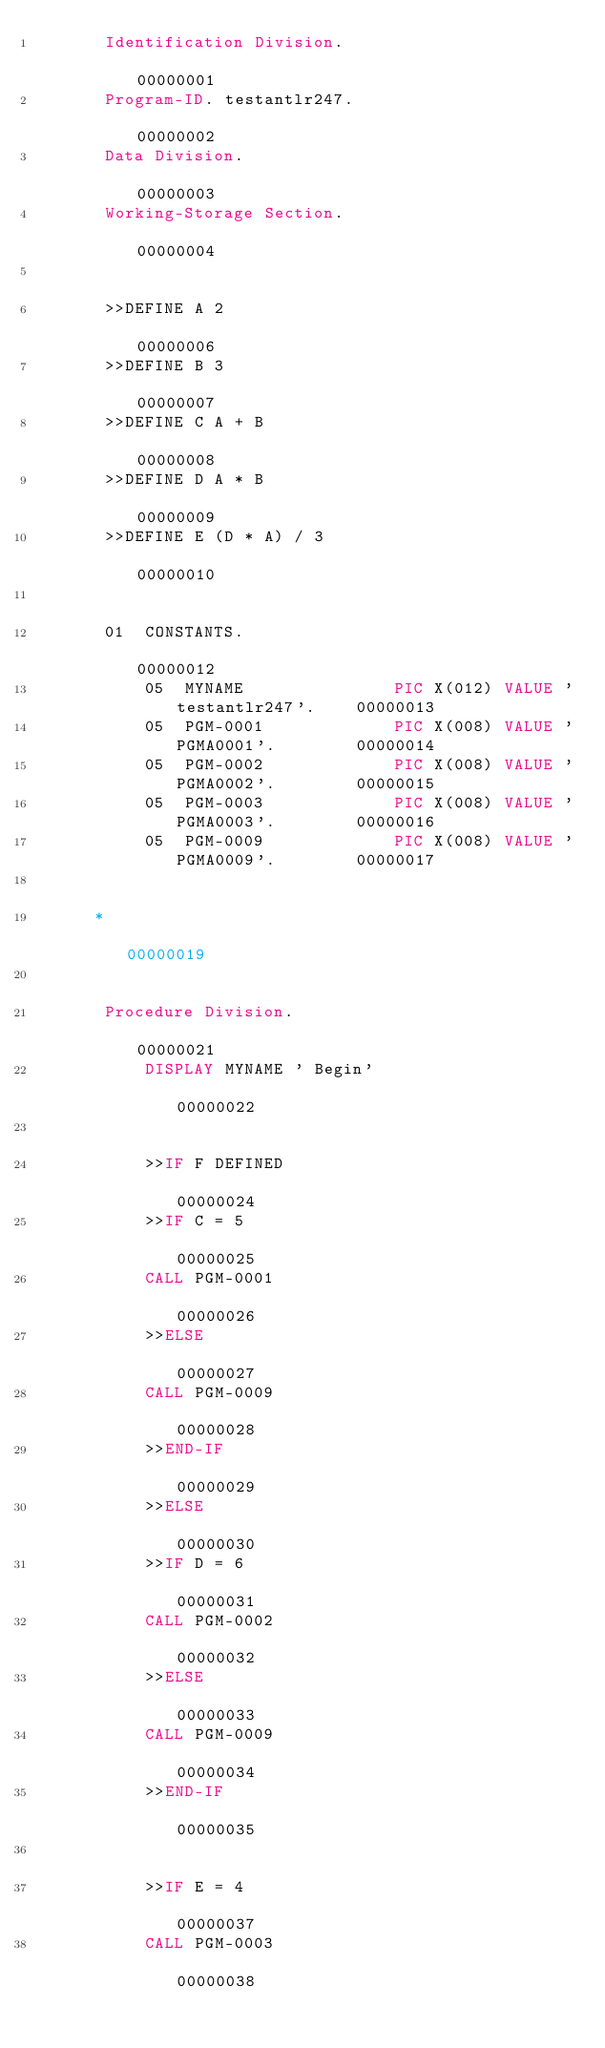<code> <loc_0><loc_0><loc_500><loc_500><_COBOL_>       Identification Division.                                         00000001
       Program-ID. testantlr247.                                        00000002
       Data Division.                                                   00000003
       Working-Storage Section.                                         00000004
                                                                        00000005
       >>DEFINE A 2                                                     00000006
       >>DEFINE B 3                                                     00000007
       >>DEFINE C A + B                                                 00000008
       >>DEFINE D A * B                                                 00000009
       >>DEFINE E (D * A) / 3                                           00000010
                                                                        00000011
       01  CONSTANTS.                                                   00000012
           05  MYNAME               PIC X(012) VALUE 'testantlr247'.    00000013
           05  PGM-0001             PIC X(008) VALUE 'PGMA0001'.        00000014
           05  PGM-0002             PIC X(008) VALUE 'PGMA0002'.        00000015
           05  PGM-0003             PIC X(008) VALUE 'PGMA0003'.        00000016
           05  PGM-0009             PIC X(008) VALUE 'PGMA0009'.        00000017
                                                                        00000018
      *                                                                 00000019
                                                                        00000020
       Procedure Division.                                              00000021
           DISPLAY MYNAME ' Begin'                                      00000022
                                                                        00000023
           >>IF F DEFINED                                               00000024
           >>IF C = 5                                                   00000025
           CALL PGM-0001                                                00000026
           >>ELSE                                                       00000027
           CALL PGM-0009                                                00000028
           >>END-IF                                                     00000029
           >>ELSE                                                       00000030
           >>IF D = 6                                                   00000031
           CALL PGM-0002                                                00000032
           >>ELSE                                                       00000033
           CALL PGM-0009                                                00000034
           >>END-IF                                                     00000035
                                                                        00000036
           >>IF E = 4                                                   00000037
           CALL PGM-0003                                                00000038</code> 